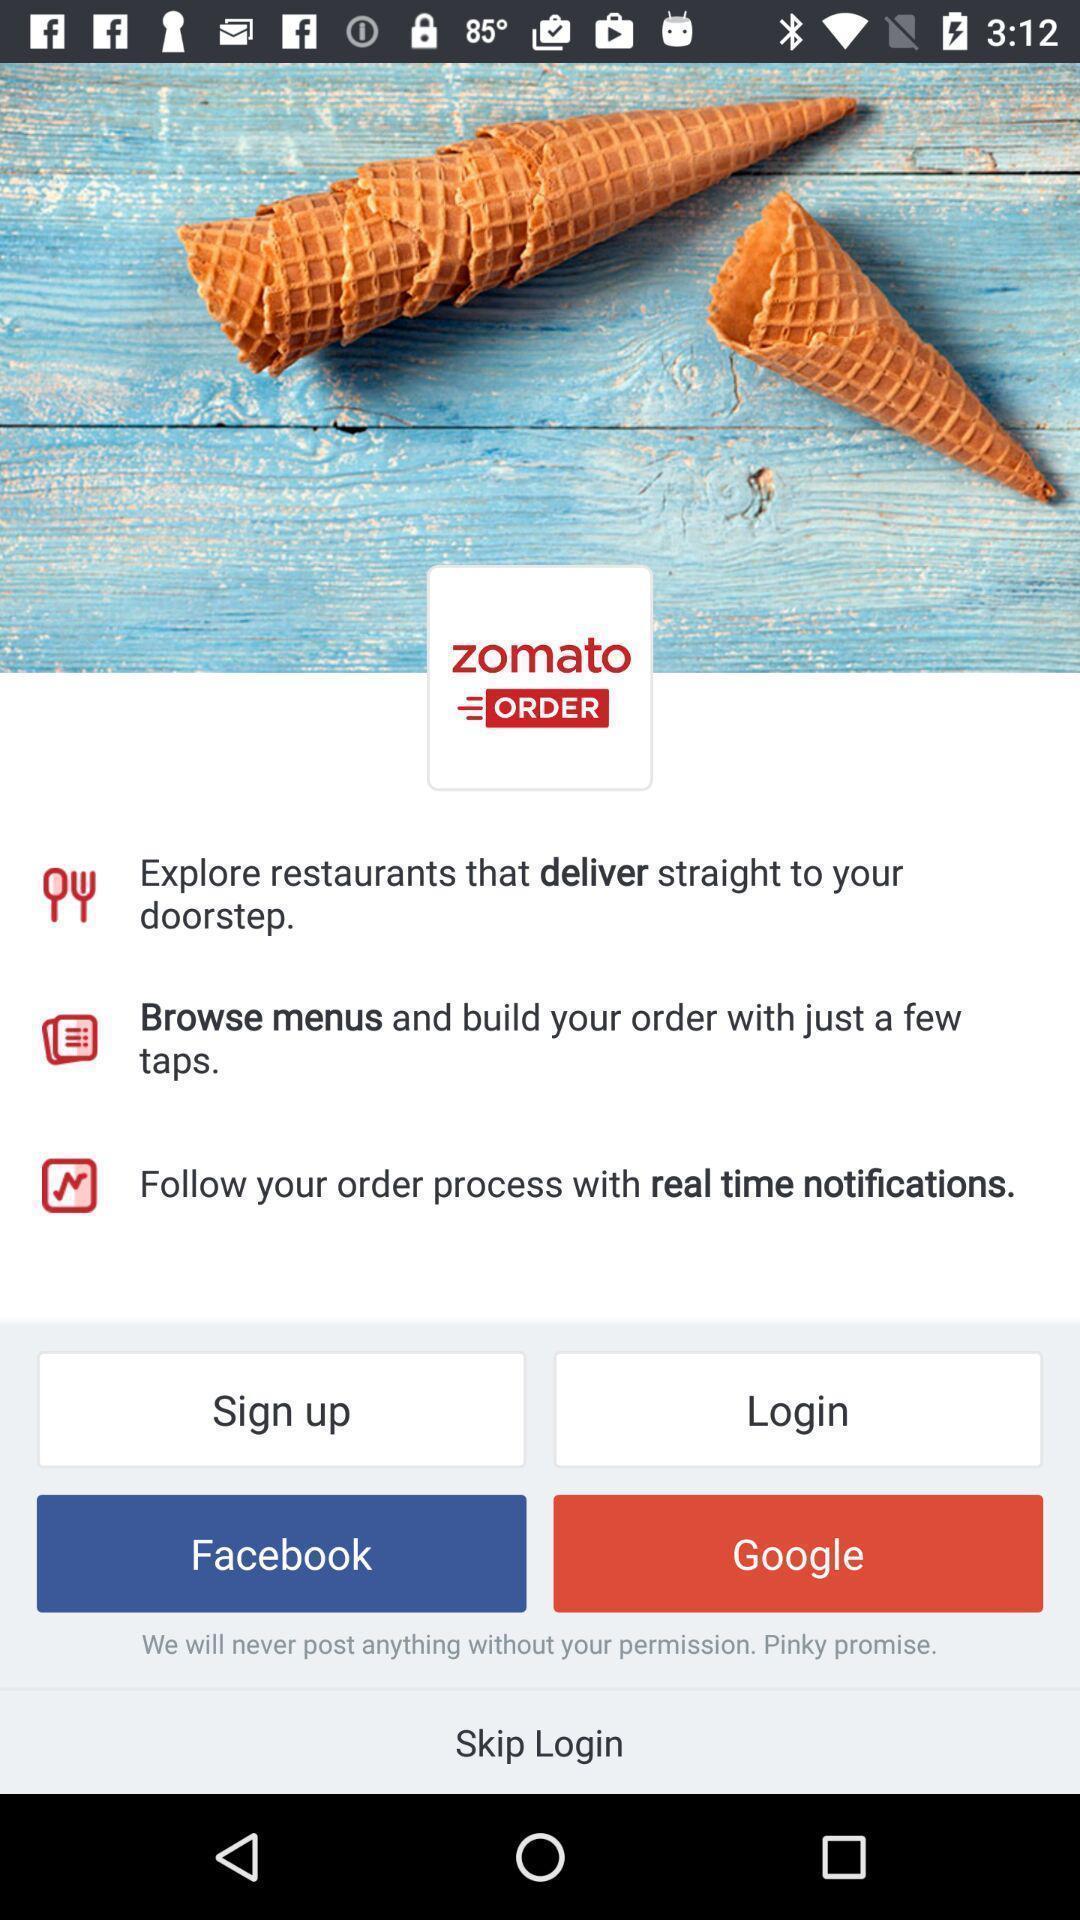Describe the visual elements of this screenshot. Welcome page of a food app. 